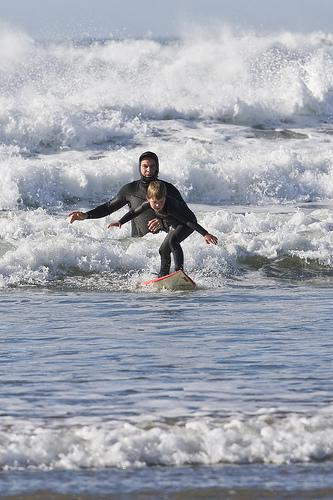Question: who is in the image?
Choices:
A. Man and woman.
B. Girl and woman.
C. Boy and girl.
D. Kid and men.
Answer with the letter. Answer: D Question: what they are doing?
Choices:
A. Riding.
B. Walking.
C. Running.
D. Skipping.
Answer with the letter. Answer: A Question: where is the image taken?
Choices:
A. The mountains.
B. The lake.
C. The zoo.
D. Near to beach.
Answer with the letter. Answer: D Question: why is the image taken?
Choices:
A. Rememberance.
B. For keepsake.
C. To forget.
D. So they can move on.
Answer with the letter. Answer: A 